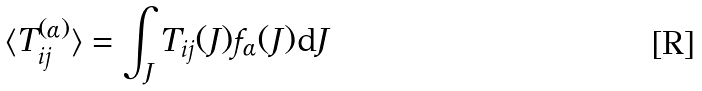<formula> <loc_0><loc_0><loc_500><loc_500>\langle T ^ { ( \alpha ) } _ { i j } \rangle = \int _ { J } T _ { i j } ( J ) f _ { \alpha } ( J ) \text {d} J</formula> 